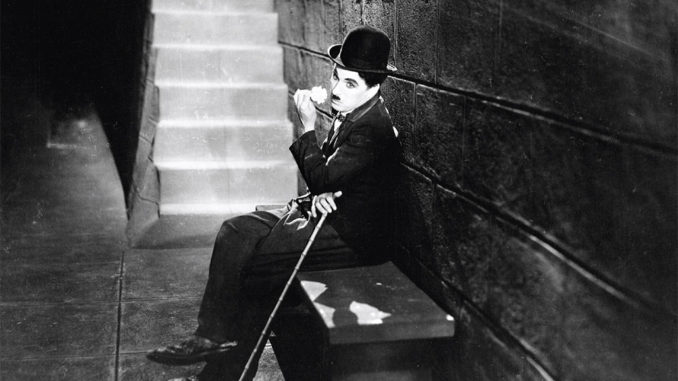Imagine the photograph as part of a dream sequence. How would you describe it? In the ethereal landscape of a dream, the familiar figure of Charlie Chaplin as the Tramp appears. He is seated on a spectral stone bench that seems to float amid an endless expanse of fog. His classic bowler hat and suit are present, yet somehow intangible, as if they might fade away at any moment. His trusty cane, a symbol of his journeys, rests lightly across his lap. The stone wall and staircase behind him are barely visible, dissolving into the mist. The Tramp's thoughtful gaze reaches beyond the realms of the waking world, searching for meaning in the shadows. The monochrome tones shift subtly, creating an ever-changing tapestry of light and darkness that envelops the scene, underscoring the ephemeral nature of dreams. 